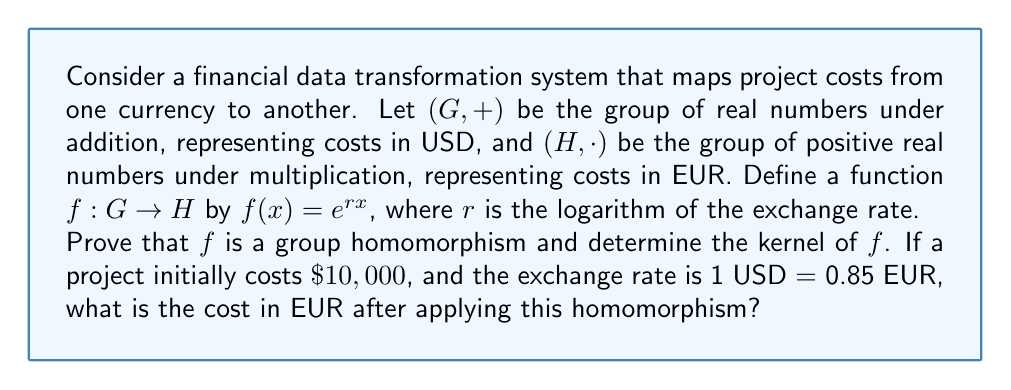Help me with this question. To prove that $f$ is a group homomorphism and find its kernel, we need to follow these steps:

1. Prove that $f$ is a homomorphism:
   For $f$ to be a homomorphism, it must satisfy $f(x+y) = f(x) \cdot f(y)$ for all $x,y \in G$.

   $f(x+y) = e^{r(x+y)} = e^{rx+ry} = e^{rx} \cdot e^{ry} = f(x) \cdot f(y)$

   Thus, $f$ is a group homomorphism.

2. Find the kernel of $f$:
   The kernel of $f$ is the set of all elements in $G$ that map to the identity element in $H$.
   In $H$, the identity element is 1.

   $\text{ker}(f) = \{x \in G : f(x) = 1\}$
   $e^{rx} = 1$
   $rx = 0$
   $x = 0$

   Therefore, $\text{ker}(f) = \{0\}$

3. Calculate the cost in EUR:
   Given: Initial cost = $\$10,000$, Exchange rate: 1 USD = 0.85 EUR
   
   First, calculate $r$:
   $e^r = 0.85$
   $r = \ln(0.85) \approx -0.1625$

   Now apply the homomorphism:
   $f(10000) = e^{r \cdot 10000} = e^{-0.1625 \cdot 10000} \approx 0.85^{10000} \approx 8500$

   The cost in EUR is approximately €8,500.
Answer: $f$ is a group homomorphism with $\text{ker}(f) = \{0\}$. The project cost in EUR after applying the homomorphism is approximately €8,500. 